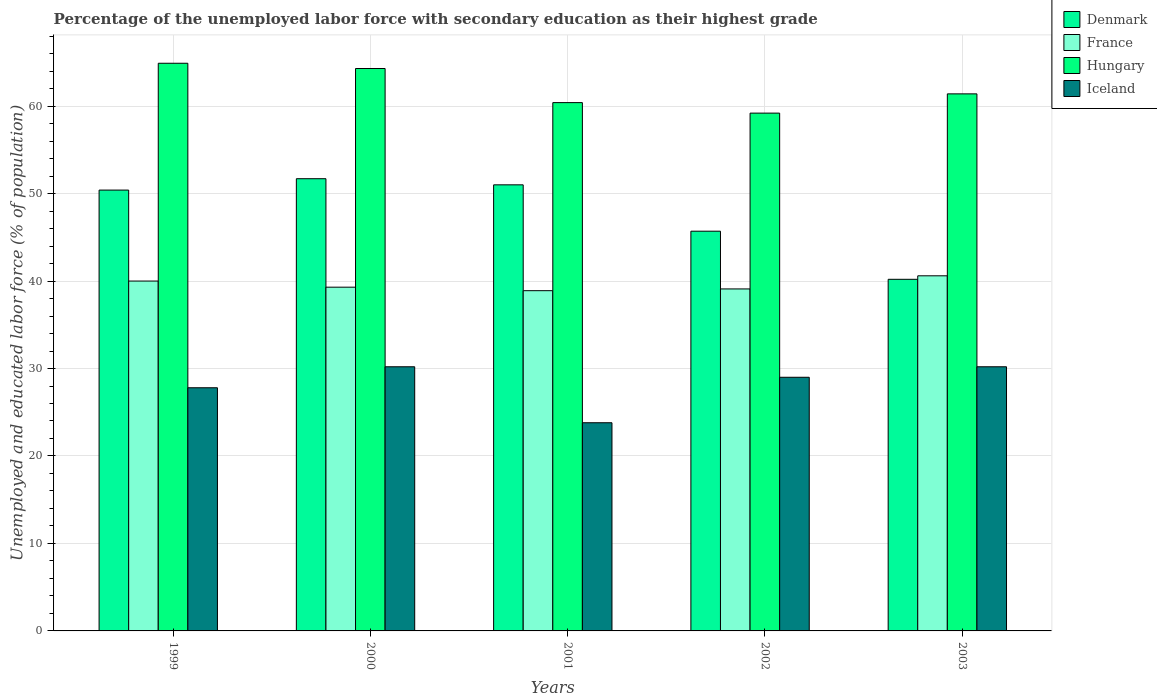How many different coloured bars are there?
Your response must be concise. 4. Are the number of bars on each tick of the X-axis equal?
Make the answer very short. Yes. How many bars are there on the 5th tick from the left?
Provide a succinct answer. 4. How many bars are there on the 5th tick from the right?
Offer a very short reply. 4. In how many cases, is the number of bars for a given year not equal to the number of legend labels?
Make the answer very short. 0. What is the percentage of the unemployed labor force with secondary education in Hungary in 2000?
Provide a succinct answer. 64.3. Across all years, what is the maximum percentage of the unemployed labor force with secondary education in Denmark?
Keep it short and to the point. 51.7. Across all years, what is the minimum percentage of the unemployed labor force with secondary education in Denmark?
Give a very brief answer. 40.2. In which year was the percentage of the unemployed labor force with secondary education in Denmark maximum?
Your answer should be very brief. 2000. What is the total percentage of the unemployed labor force with secondary education in France in the graph?
Offer a very short reply. 197.9. What is the difference between the percentage of the unemployed labor force with secondary education in France in 1999 and that in 2003?
Provide a short and direct response. -0.6. What is the difference between the percentage of the unemployed labor force with secondary education in France in 2003 and the percentage of the unemployed labor force with secondary education in Iceland in 2001?
Your response must be concise. 16.8. What is the average percentage of the unemployed labor force with secondary education in Iceland per year?
Provide a succinct answer. 28.2. In the year 2003, what is the difference between the percentage of the unemployed labor force with secondary education in Hungary and percentage of the unemployed labor force with secondary education in Iceland?
Provide a short and direct response. 31.2. What is the ratio of the percentage of the unemployed labor force with secondary education in Hungary in 2000 to that in 2002?
Offer a terse response. 1.09. Is the percentage of the unemployed labor force with secondary education in Hungary in 2001 less than that in 2002?
Provide a succinct answer. No. Is the difference between the percentage of the unemployed labor force with secondary education in Hungary in 1999 and 2000 greater than the difference between the percentage of the unemployed labor force with secondary education in Iceland in 1999 and 2000?
Give a very brief answer. Yes. What is the difference between the highest and the second highest percentage of the unemployed labor force with secondary education in France?
Provide a succinct answer. 0.6. What is the difference between the highest and the lowest percentage of the unemployed labor force with secondary education in Hungary?
Offer a terse response. 5.7. In how many years, is the percentage of the unemployed labor force with secondary education in Denmark greater than the average percentage of the unemployed labor force with secondary education in Denmark taken over all years?
Your response must be concise. 3. What does the 2nd bar from the left in 2000 represents?
Offer a very short reply. France. What does the 3rd bar from the right in 1999 represents?
Make the answer very short. France. Is it the case that in every year, the sum of the percentage of the unemployed labor force with secondary education in Denmark and percentage of the unemployed labor force with secondary education in Iceland is greater than the percentage of the unemployed labor force with secondary education in France?
Provide a short and direct response. Yes. Are the values on the major ticks of Y-axis written in scientific E-notation?
Provide a short and direct response. No. Where does the legend appear in the graph?
Your answer should be very brief. Top right. How are the legend labels stacked?
Your response must be concise. Vertical. What is the title of the graph?
Make the answer very short. Percentage of the unemployed labor force with secondary education as their highest grade. Does "Dominican Republic" appear as one of the legend labels in the graph?
Provide a short and direct response. No. What is the label or title of the X-axis?
Give a very brief answer. Years. What is the label or title of the Y-axis?
Offer a very short reply. Unemployed and educated labor force (% of population). What is the Unemployed and educated labor force (% of population) in Denmark in 1999?
Provide a short and direct response. 50.4. What is the Unemployed and educated labor force (% of population) in Hungary in 1999?
Provide a succinct answer. 64.9. What is the Unemployed and educated labor force (% of population) in Iceland in 1999?
Provide a succinct answer. 27.8. What is the Unemployed and educated labor force (% of population) in Denmark in 2000?
Offer a very short reply. 51.7. What is the Unemployed and educated labor force (% of population) in France in 2000?
Your answer should be compact. 39.3. What is the Unemployed and educated labor force (% of population) in Hungary in 2000?
Offer a terse response. 64.3. What is the Unemployed and educated labor force (% of population) of Iceland in 2000?
Provide a succinct answer. 30.2. What is the Unemployed and educated labor force (% of population) of Denmark in 2001?
Give a very brief answer. 51. What is the Unemployed and educated labor force (% of population) of France in 2001?
Keep it short and to the point. 38.9. What is the Unemployed and educated labor force (% of population) of Hungary in 2001?
Offer a terse response. 60.4. What is the Unemployed and educated labor force (% of population) of Iceland in 2001?
Provide a short and direct response. 23.8. What is the Unemployed and educated labor force (% of population) of Denmark in 2002?
Give a very brief answer. 45.7. What is the Unemployed and educated labor force (% of population) in France in 2002?
Make the answer very short. 39.1. What is the Unemployed and educated labor force (% of population) in Hungary in 2002?
Your answer should be compact. 59.2. What is the Unemployed and educated labor force (% of population) of Iceland in 2002?
Offer a very short reply. 29. What is the Unemployed and educated labor force (% of population) of Denmark in 2003?
Make the answer very short. 40.2. What is the Unemployed and educated labor force (% of population) in France in 2003?
Offer a terse response. 40.6. What is the Unemployed and educated labor force (% of population) in Hungary in 2003?
Give a very brief answer. 61.4. What is the Unemployed and educated labor force (% of population) of Iceland in 2003?
Offer a very short reply. 30.2. Across all years, what is the maximum Unemployed and educated labor force (% of population) in Denmark?
Ensure brevity in your answer.  51.7. Across all years, what is the maximum Unemployed and educated labor force (% of population) of France?
Provide a short and direct response. 40.6. Across all years, what is the maximum Unemployed and educated labor force (% of population) of Hungary?
Your answer should be compact. 64.9. Across all years, what is the maximum Unemployed and educated labor force (% of population) in Iceland?
Make the answer very short. 30.2. Across all years, what is the minimum Unemployed and educated labor force (% of population) of Denmark?
Give a very brief answer. 40.2. Across all years, what is the minimum Unemployed and educated labor force (% of population) of France?
Your answer should be very brief. 38.9. Across all years, what is the minimum Unemployed and educated labor force (% of population) of Hungary?
Give a very brief answer. 59.2. Across all years, what is the minimum Unemployed and educated labor force (% of population) of Iceland?
Your response must be concise. 23.8. What is the total Unemployed and educated labor force (% of population) of Denmark in the graph?
Ensure brevity in your answer.  239. What is the total Unemployed and educated labor force (% of population) in France in the graph?
Provide a short and direct response. 197.9. What is the total Unemployed and educated labor force (% of population) of Hungary in the graph?
Ensure brevity in your answer.  310.2. What is the total Unemployed and educated labor force (% of population) in Iceland in the graph?
Provide a succinct answer. 141. What is the difference between the Unemployed and educated labor force (% of population) in Denmark in 1999 and that in 2000?
Offer a terse response. -1.3. What is the difference between the Unemployed and educated labor force (% of population) of Hungary in 1999 and that in 2000?
Ensure brevity in your answer.  0.6. What is the difference between the Unemployed and educated labor force (% of population) of Denmark in 1999 and that in 2001?
Provide a succinct answer. -0.6. What is the difference between the Unemployed and educated labor force (% of population) in France in 1999 and that in 2001?
Offer a very short reply. 1.1. What is the difference between the Unemployed and educated labor force (% of population) of Hungary in 1999 and that in 2001?
Ensure brevity in your answer.  4.5. What is the difference between the Unemployed and educated labor force (% of population) in Iceland in 1999 and that in 2001?
Make the answer very short. 4. What is the difference between the Unemployed and educated labor force (% of population) in France in 1999 and that in 2002?
Keep it short and to the point. 0.9. What is the difference between the Unemployed and educated labor force (% of population) of Hungary in 1999 and that in 2002?
Your answer should be very brief. 5.7. What is the difference between the Unemployed and educated labor force (% of population) in Iceland in 1999 and that in 2002?
Your response must be concise. -1.2. What is the difference between the Unemployed and educated labor force (% of population) in Hungary in 1999 and that in 2003?
Give a very brief answer. 3.5. What is the difference between the Unemployed and educated labor force (% of population) in Iceland in 1999 and that in 2003?
Keep it short and to the point. -2.4. What is the difference between the Unemployed and educated labor force (% of population) in France in 2000 and that in 2001?
Your answer should be compact. 0.4. What is the difference between the Unemployed and educated labor force (% of population) in Iceland in 2000 and that in 2001?
Ensure brevity in your answer.  6.4. What is the difference between the Unemployed and educated labor force (% of population) of Denmark in 2000 and that in 2002?
Ensure brevity in your answer.  6. What is the difference between the Unemployed and educated labor force (% of population) of Hungary in 2000 and that in 2003?
Make the answer very short. 2.9. What is the difference between the Unemployed and educated labor force (% of population) of Iceland in 2000 and that in 2003?
Your response must be concise. 0. What is the difference between the Unemployed and educated labor force (% of population) of Denmark in 2001 and that in 2002?
Your response must be concise. 5.3. What is the difference between the Unemployed and educated labor force (% of population) in Hungary in 2001 and that in 2002?
Make the answer very short. 1.2. What is the difference between the Unemployed and educated labor force (% of population) of Denmark in 2001 and that in 2003?
Give a very brief answer. 10.8. What is the difference between the Unemployed and educated labor force (% of population) in France in 2001 and that in 2003?
Provide a succinct answer. -1.7. What is the difference between the Unemployed and educated labor force (% of population) of Iceland in 2001 and that in 2003?
Ensure brevity in your answer.  -6.4. What is the difference between the Unemployed and educated labor force (% of population) in France in 2002 and that in 2003?
Offer a very short reply. -1.5. What is the difference between the Unemployed and educated labor force (% of population) in Hungary in 2002 and that in 2003?
Offer a very short reply. -2.2. What is the difference between the Unemployed and educated labor force (% of population) of Iceland in 2002 and that in 2003?
Offer a terse response. -1.2. What is the difference between the Unemployed and educated labor force (% of population) of Denmark in 1999 and the Unemployed and educated labor force (% of population) of France in 2000?
Keep it short and to the point. 11.1. What is the difference between the Unemployed and educated labor force (% of population) in Denmark in 1999 and the Unemployed and educated labor force (% of population) in Iceland in 2000?
Make the answer very short. 20.2. What is the difference between the Unemployed and educated labor force (% of population) of France in 1999 and the Unemployed and educated labor force (% of population) of Hungary in 2000?
Your answer should be very brief. -24.3. What is the difference between the Unemployed and educated labor force (% of population) in France in 1999 and the Unemployed and educated labor force (% of population) in Iceland in 2000?
Give a very brief answer. 9.8. What is the difference between the Unemployed and educated labor force (% of population) in Hungary in 1999 and the Unemployed and educated labor force (% of population) in Iceland in 2000?
Ensure brevity in your answer.  34.7. What is the difference between the Unemployed and educated labor force (% of population) of Denmark in 1999 and the Unemployed and educated labor force (% of population) of Iceland in 2001?
Your response must be concise. 26.6. What is the difference between the Unemployed and educated labor force (% of population) in France in 1999 and the Unemployed and educated labor force (% of population) in Hungary in 2001?
Provide a succinct answer. -20.4. What is the difference between the Unemployed and educated labor force (% of population) of France in 1999 and the Unemployed and educated labor force (% of population) of Iceland in 2001?
Ensure brevity in your answer.  16.2. What is the difference between the Unemployed and educated labor force (% of population) in Hungary in 1999 and the Unemployed and educated labor force (% of population) in Iceland in 2001?
Provide a short and direct response. 41.1. What is the difference between the Unemployed and educated labor force (% of population) of Denmark in 1999 and the Unemployed and educated labor force (% of population) of Iceland in 2002?
Keep it short and to the point. 21.4. What is the difference between the Unemployed and educated labor force (% of population) of France in 1999 and the Unemployed and educated labor force (% of population) of Hungary in 2002?
Offer a terse response. -19.2. What is the difference between the Unemployed and educated labor force (% of population) in France in 1999 and the Unemployed and educated labor force (% of population) in Iceland in 2002?
Provide a succinct answer. 11. What is the difference between the Unemployed and educated labor force (% of population) of Hungary in 1999 and the Unemployed and educated labor force (% of population) of Iceland in 2002?
Provide a succinct answer. 35.9. What is the difference between the Unemployed and educated labor force (% of population) of Denmark in 1999 and the Unemployed and educated labor force (% of population) of Iceland in 2003?
Your answer should be very brief. 20.2. What is the difference between the Unemployed and educated labor force (% of population) in France in 1999 and the Unemployed and educated labor force (% of population) in Hungary in 2003?
Give a very brief answer. -21.4. What is the difference between the Unemployed and educated labor force (% of population) in France in 1999 and the Unemployed and educated labor force (% of population) in Iceland in 2003?
Give a very brief answer. 9.8. What is the difference between the Unemployed and educated labor force (% of population) in Hungary in 1999 and the Unemployed and educated labor force (% of population) in Iceland in 2003?
Provide a short and direct response. 34.7. What is the difference between the Unemployed and educated labor force (% of population) of Denmark in 2000 and the Unemployed and educated labor force (% of population) of France in 2001?
Your response must be concise. 12.8. What is the difference between the Unemployed and educated labor force (% of population) of Denmark in 2000 and the Unemployed and educated labor force (% of population) of Iceland in 2001?
Provide a succinct answer. 27.9. What is the difference between the Unemployed and educated labor force (% of population) of France in 2000 and the Unemployed and educated labor force (% of population) of Hungary in 2001?
Your answer should be compact. -21.1. What is the difference between the Unemployed and educated labor force (% of population) in Hungary in 2000 and the Unemployed and educated labor force (% of population) in Iceland in 2001?
Keep it short and to the point. 40.5. What is the difference between the Unemployed and educated labor force (% of population) of Denmark in 2000 and the Unemployed and educated labor force (% of population) of Iceland in 2002?
Offer a terse response. 22.7. What is the difference between the Unemployed and educated labor force (% of population) of France in 2000 and the Unemployed and educated labor force (% of population) of Hungary in 2002?
Offer a terse response. -19.9. What is the difference between the Unemployed and educated labor force (% of population) in France in 2000 and the Unemployed and educated labor force (% of population) in Iceland in 2002?
Ensure brevity in your answer.  10.3. What is the difference between the Unemployed and educated labor force (% of population) in Hungary in 2000 and the Unemployed and educated labor force (% of population) in Iceland in 2002?
Offer a terse response. 35.3. What is the difference between the Unemployed and educated labor force (% of population) in France in 2000 and the Unemployed and educated labor force (% of population) in Hungary in 2003?
Keep it short and to the point. -22.1. What is the difference between the Unemployed and educated labor force (% of population) of France in 2000 and the Unemployed and educated labor force (% of population) of Iceland in 2003?
Ensure brevity in your answer.  9.1. What is the difference between the Unemployed and educated labor force (% of population) of Hungary in 2000 and the Unemployed and educated labor force (% of population) of Iceland in 2003?
Make the answer very short. 34.1. What is the difference between the Unemployed and educated labor force (% of population) in Denmark in 2001 and the Unemployed and educated labor force (% of population) in Hungary in 2002?
Your answer should be very brief. -8.2. What is the difference between the Unemployed and educated labor force (% of population) of Denmark in 2001 and the Unemployed and educated labor force (% of population) of Iceland in 2002?
Keep it short and to the point. 22. What is the difference between the Unemployed and educated labor force (% of population) in France in 2001 and the Unemployed and educated labor force (% of population) in Hungary in 2002?
Offer a terse response. -20.3. What is the difference between the Unemployed and educated labor force (% of population) in Hungary in 2001 and the Unemployed and educated labor force (% of population) in Iceland in 2002?
Your response must be concise. 31.4. What is the difference between the Unemployed and educated labor force (% of population) of Denmark in 2001 and the Unemployed and educated labor force (% of population) of France in 2003?
Your answer should be compact. 10.4. What is the difference between the Unemployed and educated labor force (% of population) in Denmark in 2001 and the Unemployed and educated labor force (% of population) in Iceland in 2003?
Provide a succinct answer. 20.8. What is the difference between the Unemployed and educated labor force (% of population) of France in 2001 and the Unemployed and educated labor force (% of population) of Hungary in 2003?
Your answer should be compact. -22.5. What is the difference between the Unemployed and educated labor force (% of population) in Hungary in 2001 and the Unemployed and educated labor force (% of population) in Iceland in 2003?
Your answer should be compact. 30.2. What is the difference between the Unemployed and educated labor force (% of population) of Denmark in 2002 and the Unemployed and educated labor force (% of population) of France in 2003?
Keep it short and to the point. 5.1. What is the difference between the Unemployed and educated labor force (% of population) in Denmark in 2002 and the Unemployed and educated labor force (% of population) in Hungary in 2003?
Make the answer very short. -15.7. What is the difference between the Unemployed and educated labor force (% of population) of Denmark in 2002 and the Unemployed and educated labor force (% of population) of Iceland in 2003?
Ensure brevity in your answer.  15.5. What is the difference between the Unemployed and educated labor force (% of population) in France in 2002 and the Unemployed and educated labor force (% of population) in Hungary in 2003?
Ensure brevity in your answer.  -22.3. What is the difference between the Unemployed and educated labor force (% of population) in France in 2002 and the Unemployed and educated labor force (% of population) in Iceland in 2003?
Ensure brevity in your answer.  8.9. What is the average Unemployed and educated labor force (% of population) of Denmark per year?
Make the answer very short. 47.8. What is the average Unemployed and educated labor force (% of population) in France per year?
Your response must be concise. 39.58. What is the average Unemployed and educated labor force (% of population) in Hungary per year?
Your answer should be compact. 62.04. What is the average Unemployed and educated labor force (% of population) in Iceland per year?
Your answer should be compact. 28.2. In the year 1999, what is the difference between the Unemployed and educated labor force (% of population) in Denmark and Unemployed and educated labor force (% of population) in France?
Make the answer very short. 10.4. In the year 1999, what is the difference between the Unemployed and educated labor force (% of population) of Denmark and Unemployed and educated labor force (% of population) of Iceland?
Keep it short and to the point. 22.6. In the year 1999, what is the difference between the Unemployed and educated labor force (% of population) in France and Unemployed and educated labor force (% of population) in Hungary?
Make the answer very short. -24.9. In the year 1999, what is the difference between the Unemployed and educated labor force (% of population) in France and Unemployed and educated labor force (% of population) in Iceland?
Provide a short and direct response. 12.2. In the year 1999, what is the difference between the Unemployed and educated labor force (% of population) of Hungary and Unemployed and educated labor force (% of population) of Iceland?
Provide a short and direct response. 37.1. In the year 2000, what is the difference between the Unemployed and educated labor force (% of population) of Denmark and Unemployed and educated labor force (% of population) of France?
Provide a succinct answer. 12.4. In the year 2000, what is the difference between the Unemployed and educated labor force (% of population) of France and Unemployed and educated labor force (% of population) of Iceland?
Offer a terse response. 9.1. In the year 2000, what is the difference between the Unemployed and educated labor force (% of population) in Hungary and Unemployed and educated labor force (% of population) in Iceland?
Your answer should be compact. 34.1. In the year 2001, what is the difference between the Unemployed and educated labor force (% of population) in Denmark and Unemployed and educated labor force (% of population) in France?
Ensure brevity in your answer.  12.1. In the year 2001, what is the difference between the Unemployed and educated labor force (% of population) in Denmark and Unemployed and educated labor force (% of population) in Iceland?
Provide a succinct answer. 27.2. In the year 2001, what is the difference between the Unemployed and educated labor force (% of population) of France and Unemployed and educated labor force (% of population) of Hungary?
Offer a very short reply. -21.5. In the year 2001, what is the difference between the Unemployed and educated labor force (% of population) in France and Unemployed and educated labor force (% of population) in Iceland?
Give a very brief answer. 15.1. In the year 2001, what is the difference between the Unemployed and educated labor force (% of population) of Hungary and Unemployed and educated labor force (% of population) of Iceland?
Provide a short and direct response. 36.6. In the year 2002, what is the difference between the Unemployed and educated labor force (% of population) in Denmark and Unemployed and educated labor force (% of population) in France?
Offer a terse response. 6.6. In the year 2002, what is the difference between the Unemployed and educated labor force (% of population) in France and Unemployed and educated labor force (% of population) in Hungary?
Make the answer very short. -20.1. In the year 2002, what is the difference between the Unemployed and educated labor force (% of population) of Hungary and Unemployed and educated labor force (% of population) of Iceland?
Provide a short and direct response. 30.2. In the year 2003, what is the difference between the Unemployed and educated labor force (% of population) of Denmark and Unemployed and educated labor force (% of population) of Hungary?
Your response must be concise. -21.2. In the year 2003, what is the difference between the Unemployed and educated labor force (% of population) of France and Unemployed and educated labor force (% of population) of Hungary?
Your response must be concise. -20.8. In the year 2003, what is the difference between the Unemployed and educated labor force (% of population) of France and Unemployed and educated labor force (% of population) of Iceland?
Offer a very short reply. 10.4. In the year 2003, what is the difference between the Unemployed and educated labor force (% of population) of Hungary and Unemployed and educated labor force (% of population) of Iceland?
Your response must be concise. 31.2. What is the ratio of the Unemployed and educated labor force (% of population) in Denmark in 1999 to that in 2000?
Your response must be concise. 0.97. What is the ratio of the Unemployed and educated labor force (% of population) in France in 1999 to that in 2000?
Provide a succinct answer. 1.02. What is the ratio of the Unemployed and educated labor force (% of population) in Hungary in 1999 to that in 2000?
Your response must be concise. 1.01. What is the ratio of the Unemployed and educated labor force (% of population) of Iceland in 1999 to that in 2000?
Ensure brevity in your answer.  0.92. What is the ratio of the Unemployed and educated labor force (% of population) in France in 1999 to that in 2001?
Your response must be concise. 1.03. What is the ratio of the Unemployed and educated labor force (% of population) in Hungary in 1999 to that in 2001?
Ensure brevity in your answer.  1.07. What is the ratio of the Unemployed and educated labor force (% of population) in Iceland in 1999 to that in 2001?
Offer a terse response. 1.17. What is the ratio of the Unemployed and educated labor force (% of population) in Denmark in 1999 to that in 2002?
Offer a very short reply. 1.1. What is the ratio of the Unemployed and educated labor force (% of population) in France in 1999 to that in 2002?
Offer a very short reply. 1.02. What is the ratio of the Unemployed and educated labor force (% of population) of Hungary in 1999 to that in 2002?
Your answer should be compact. 1.1. What is the ratio of the Unemployed and educated labor force (% of population) of Iceland in 1999 to that in 2002?
Make the answer very short. 0.96. What is the ratio of the Unemployed and educated labor force (% of population) in Denmark in 1999 to that in 2003?
Ensure brevity in your answer.  1.25. What is the ratio of the Unemployed and educated labor force (% of population) of France in 1999 to that in 2003?
Your answer should be compact. 0.99. What is the ratio of the Unemployed and educated labor force (% of population) in Hungary in 1999 to that in 2003?
Your answer should be very brief. 1.06. What is the ratio of the Unemployed and educated labor force (% of population) of Iceland in 1999 to that in 2003?
Offer a very short reply. 0.92. What is the ratio of the Unemployed and educated labor force (% of population) in Denmark in 2000 to that in 2001?
Make the answer very short. 1.01. What is the ratio of the Unemployed and educated labor force (% of population) of France in 2000 to that in 2001?
Offer a terse response. 1.01. What is the ratio of the Unemployed and educated labor force (% of population) in Hungary in 2000 to that in 2001?
Make the answer very short. 1.06. What is the ratio of the Unemployed and educated labor force (% of population) of Iceland in 2000 to that in 2001?
Offer a terse response. 1.27. What is the ratio of the Unemployed and educated labor force (% of population) in Denmark in 2000 to that in 2002?
Your answer should be very brief. 1.13. What is the ratio of the Unemployed and educated labor force (% of population) in Hungary in 2000 to that in 2002?
Offer a very short reply. 1.09. What is the ratio of the Unemployed and educated labor force (% of population) in Iceland in 2000 to that in 2002?
Provide a short and direct response. 1.04. What is the ratio of the Unemployed and educated labor force (% of population) in Denmark in 2000 to that in 2003?
Your answer should be compact. 1.29. What is the ratio of the Unemployed and educated labor force (% of population) of Hungary in 2000 to that in 2003?
Give a very brief answer. 1.05. What is the ratio of the Unemployed and educated labor force (% of population) in Iceland in 2000 to that in 2003?
Keep it short and to the point. 1. What is the ratio of the Unemployed and educated labor force (% of population) of Denmark in 2001 to that in 2002?
Offer a terse response. 1.12. What is the ratio of the Unemployed and educated labor force (% of population) in France in 2001 to that in 2002?
Give a very brief answer. 0.99. What is the ratio of the Unemployed and educated labor force (% of population) of Hungary in 2001 to that in 2002?
Give a very brief answer. 1.02. What is the ratio of the Unemployed and educated labor force (% of population) in Iceland in 2001 to that in 2002?
Keep it short and to the point. 0.82. What is the ratio of the Unemployed and educated labor force (% of population) of Denmark in 2001 to that in 2003?
Provide a short and direct response. 1.27. What is the ratio of the Unemployed and educated labor force (% of population) of France in 2001 to that in 2003?
Your answer should be very brief. 0.96. What is the ratio of the Unemployed and educated labor force (% of population) of Hungary in 2001 to that in 2003?
Ensure brevity in your answer.  0.98. What is the ratio of the Unemployed and educated labor force (% of population) of Iceland in 2001 to that in 2003?
Your answer should be compact. 0.79. What is the ratio of the Unemployed and educated labor force (% of population) of Denmark in 2002 to that in 2003?
Make the answer very short. 1.14. What is the ratio of the Unemployed and educated labor force (% of population) of France in 2002 to that in 2003?
Your response must be concise. 0.96. What is the ratio of the Unemployed and educated labor force (% of population) of Hungary in 2002 to that in 2003?
Make the answer very short. 0.96. What is the ratio of the Unemployed and educated labor force (% of population) of Iceland in 2002 to that in 2003?
Give a very brief answer. 0.96. What is the difference between the highest and the second highest Unemployed and educated labor force (% of population) of France?
Your answer should be compact. 0.6. What is the difference between the highest and the second highest Unemployed and educated labor force (% of population) in Iceland?
Make the answer very short. 0. What is the difference between the highest and the lowest Unemployed and educated labor force (% of population) in France?
Ensure brevity in your answer.  1.7. What is the difference between the highest and the lowest Unemployed and educated labor force (% of population) of Hungary?
Provide a succinct answer. 5.7. What is the difference between the highest and the lowest Unemployed and educated labor force (% of population) of Iceland?
Keep it short and to the point. 6.4. 